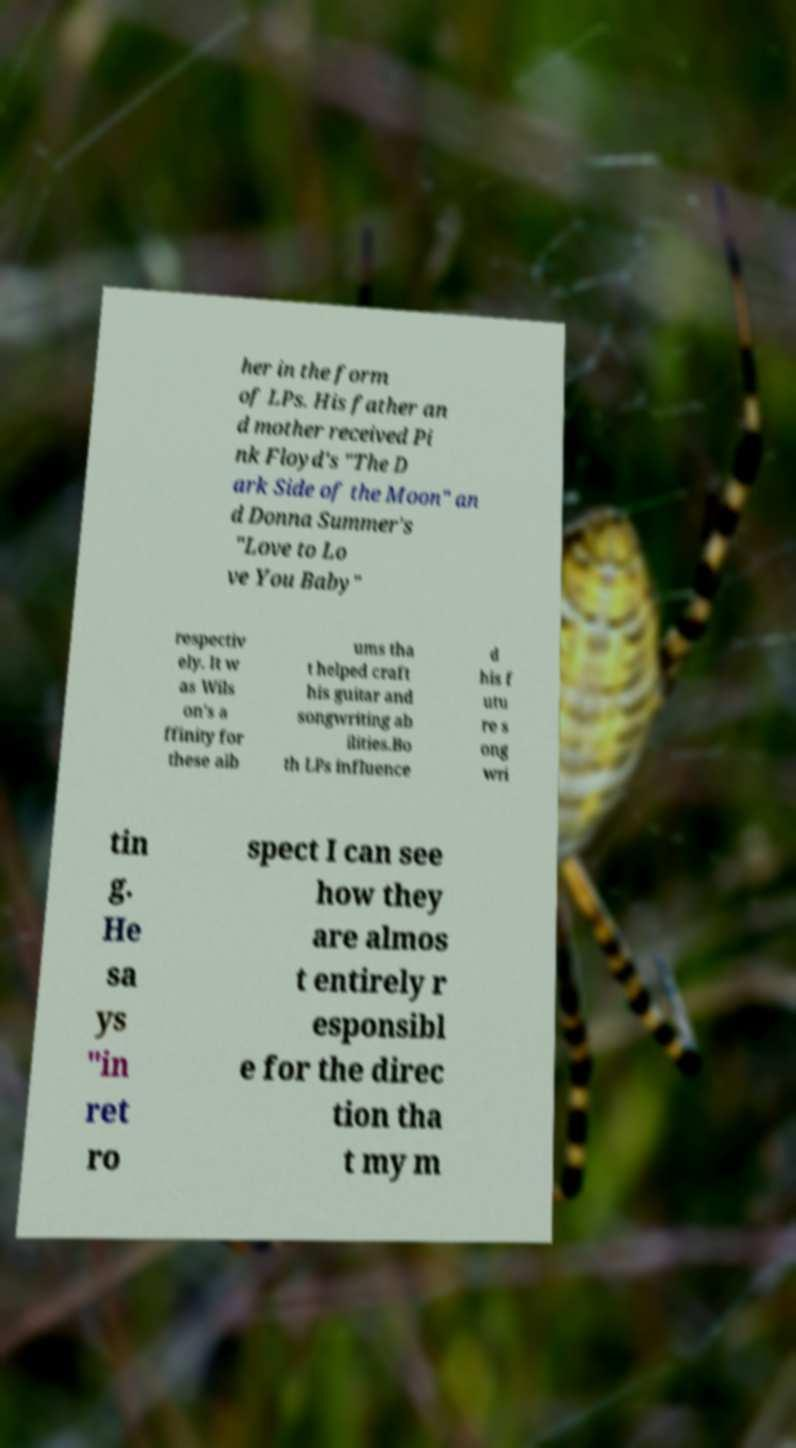What messages or text are displayed in this image? I need them in a readable, typed format. her in the form of LPs. His father an d mother received Pi nk Floyd's "The D ark Side of the Moon" an d Donna Summer's "Love to Lo ve You Baby" respectiv ely. It w as Wils on's a ffinity for these alb ums tha t helped craft his guitar and songwriting ab ilities.Bo th LPs influence d his f utu re s ong wri tin g. He sa ys "in ret ro spect I can see how they are almos t entirely r esponsibl e for the direc tion tha t my m 